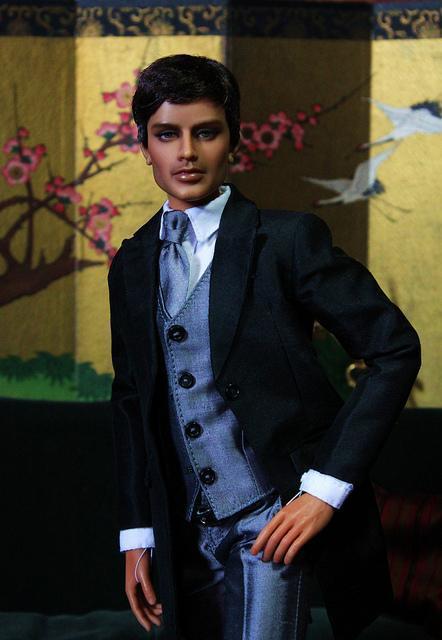How many buttons are on the shirt?
Give a very brief answer. 4. 